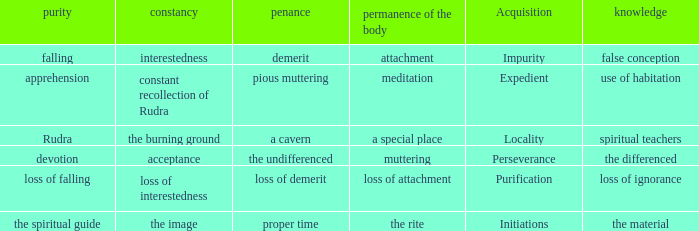 what's the permanence of the body where penance is the undifferenced Muttering. 